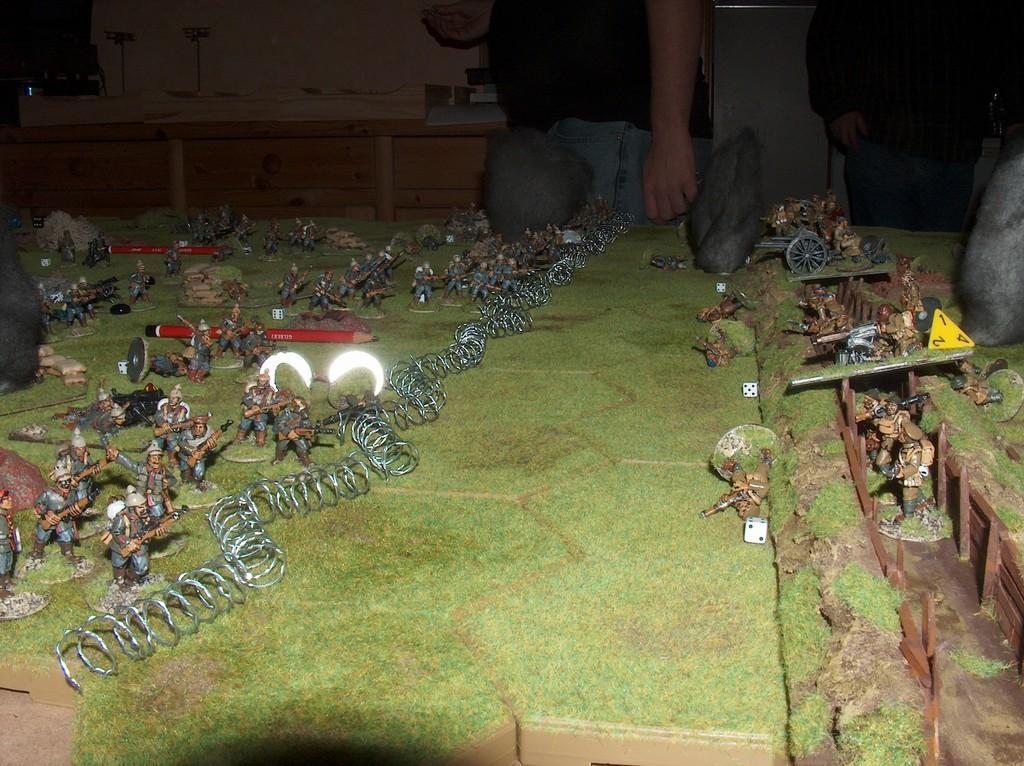Describe this image in one or two sentences. In this picture we can see a miniature, there are two pencils, some toys, and springs present on the left side, on the right side we can see dice, in the background there are two persons standing, we can see drawers here. 